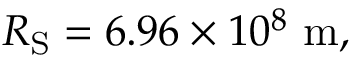Convert formula to latex. <formula><loc_0><loc_0><loc_500><loc_500>R _ { S } = 6 . 9 6 \times 1 0 ^ { 8 } \ m ,</formula> 